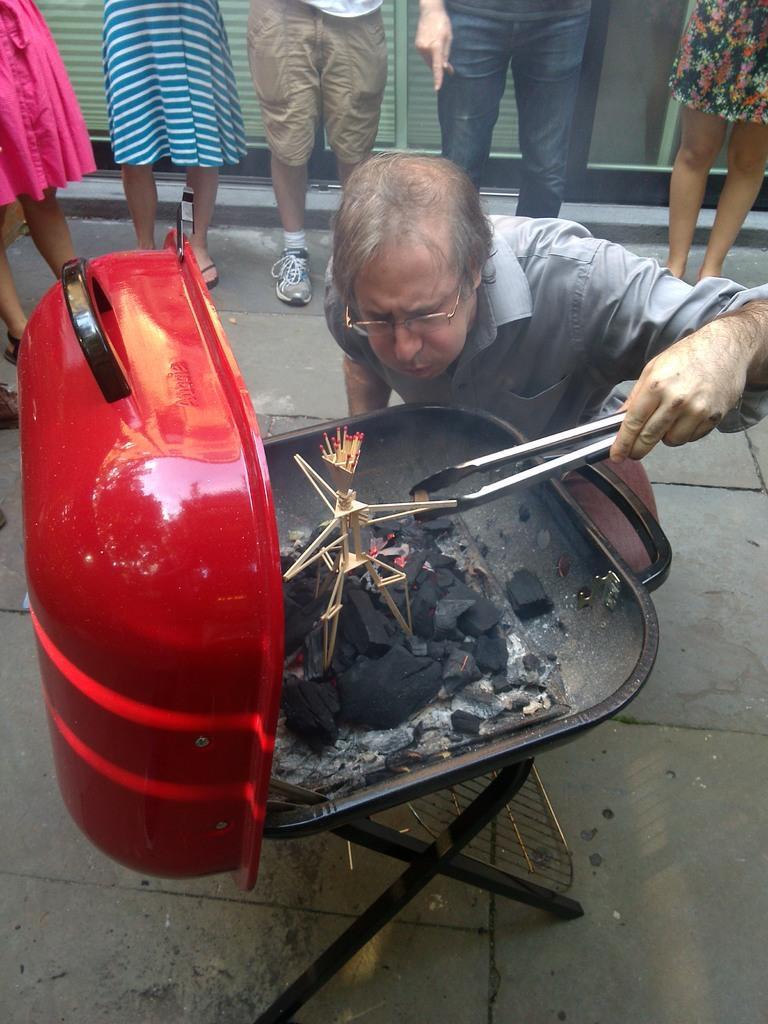Please provide a concise description of this image. In this image, we can see a few people. Among them, we can see a person holding an object. We can see some coal and match sticks in an object which is placed on a stool. We can also see the ground. 